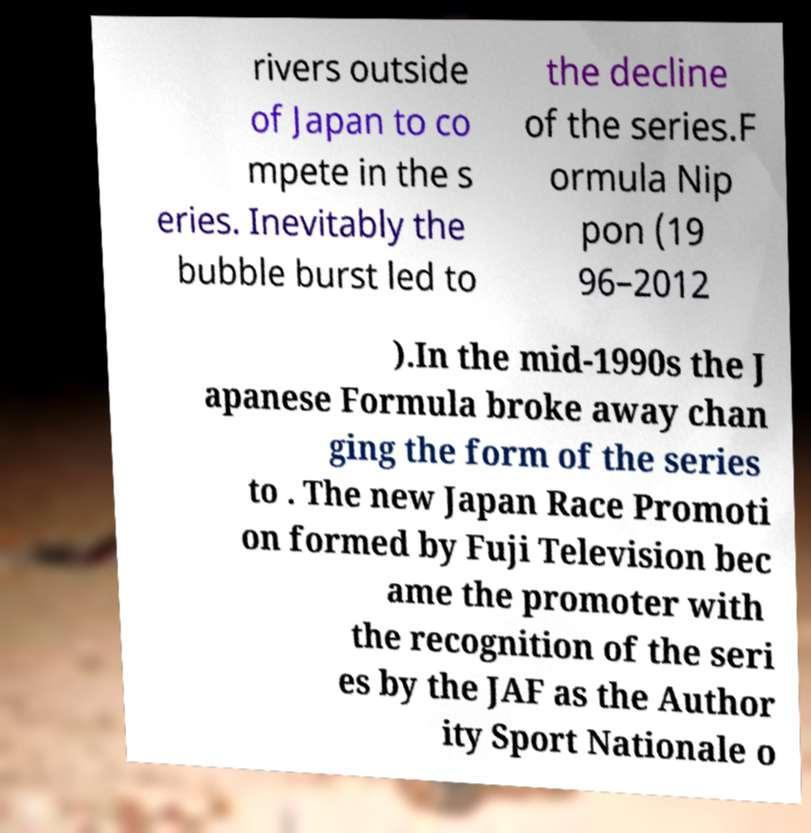Could you extract and type out the text from this image? rivers outside of Japan to co mpete in the s eries. Inevitably the bubble burst led to the decline of the series.F ormula Nip pon (19 96–2012 ).In the mid-1990s the J apanese Formula broke away chan ging the form of the series to . The new Japan Race Promoti on formed by Fuji Television bec ame the promoter with the recognition of the seri es by the JAF as the Author ity Sport Nationale o 